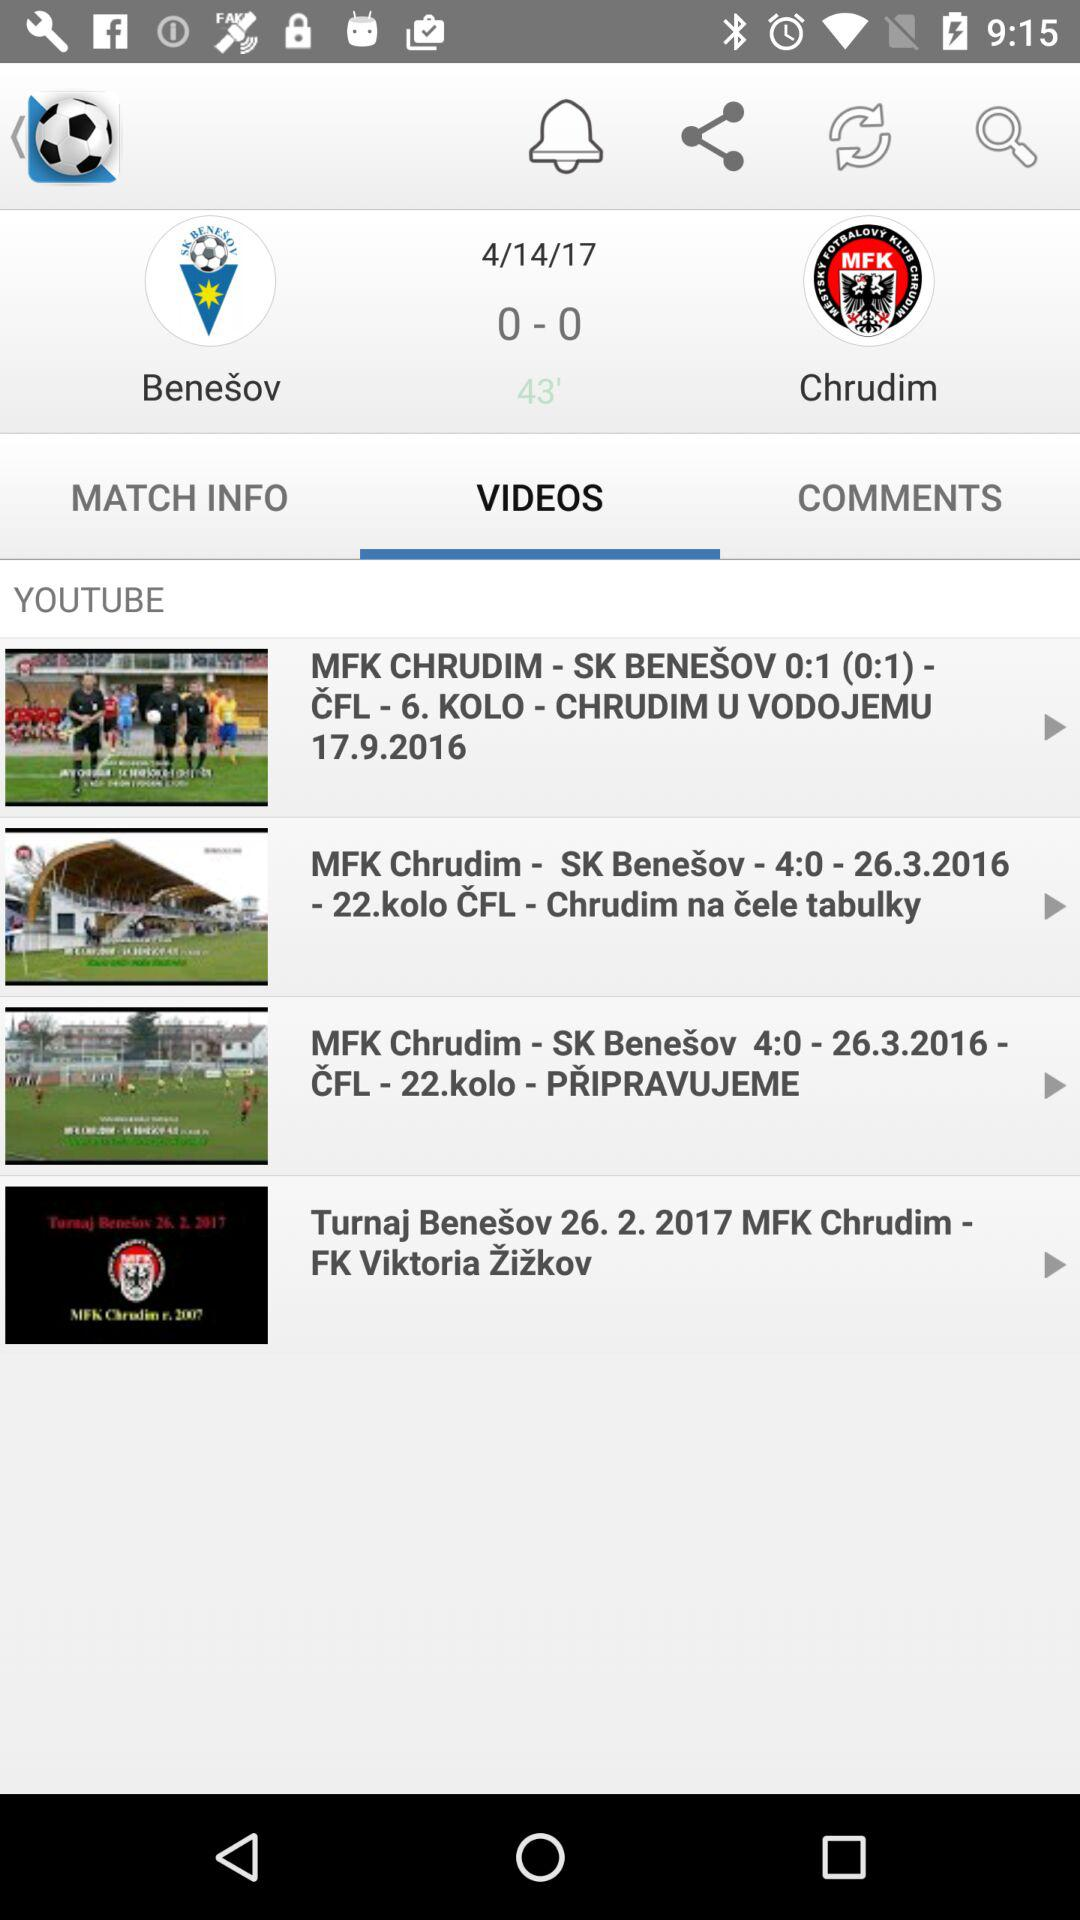Which tab am I on? You are on the "VIDEOS" tab. 